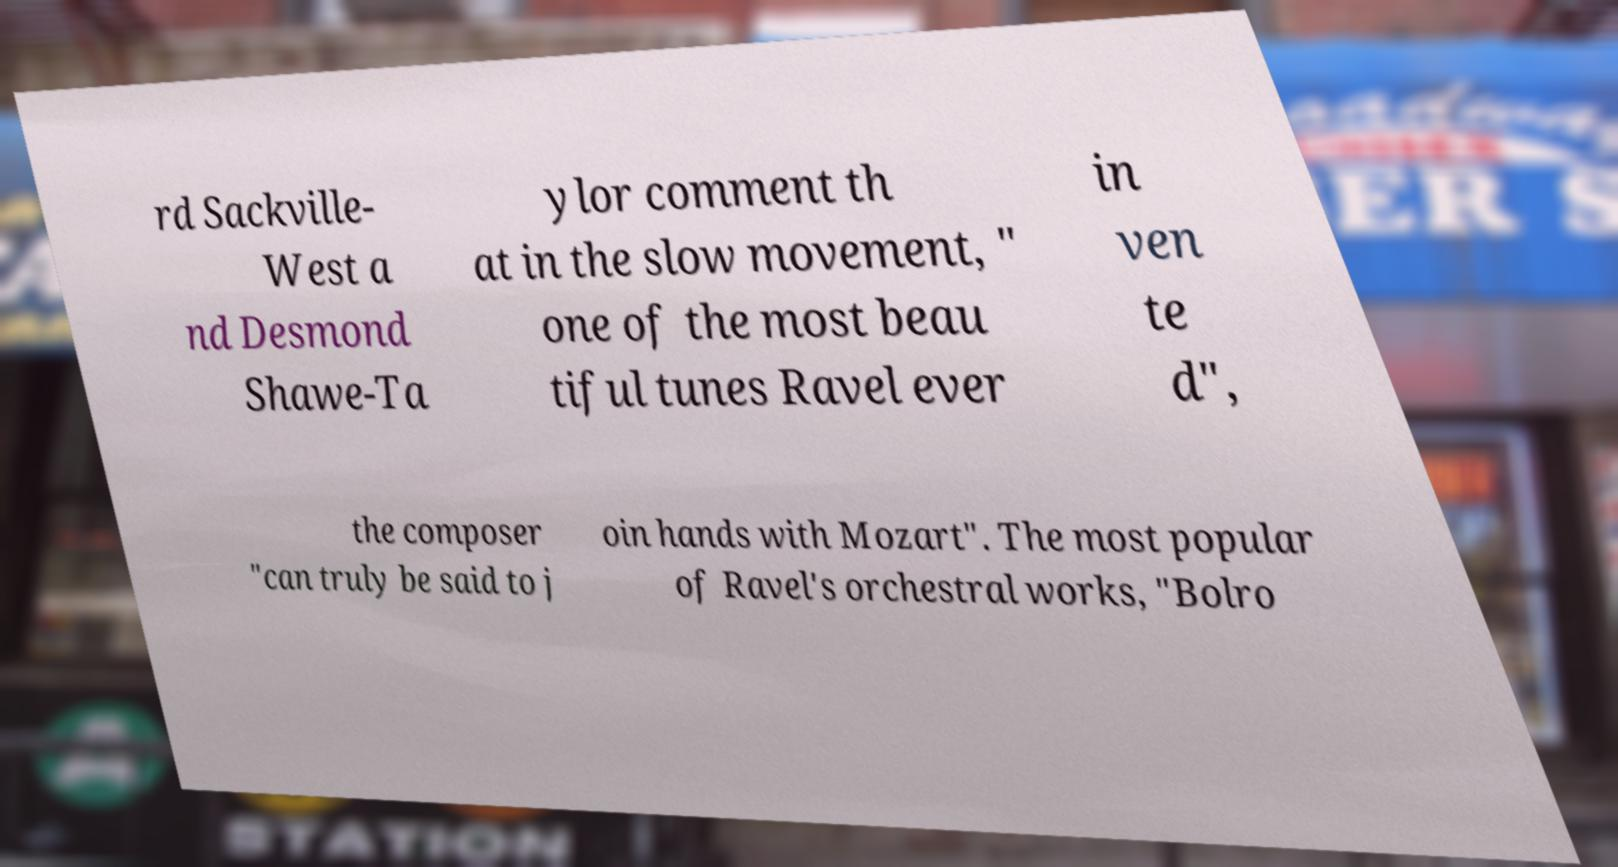There's text embedded in this image that I need extracted. Can you transcribe it verbatim? rd Sackville- West a nd Desmond Shawe-Ta ylor comment th at in the slow movement, " one of the most beau tiful tunes Ravel ever in ven te d", the composer "can truly be said to j oin hands with Mozart". The most popular of Ravel's orchestral works, "Bolro 